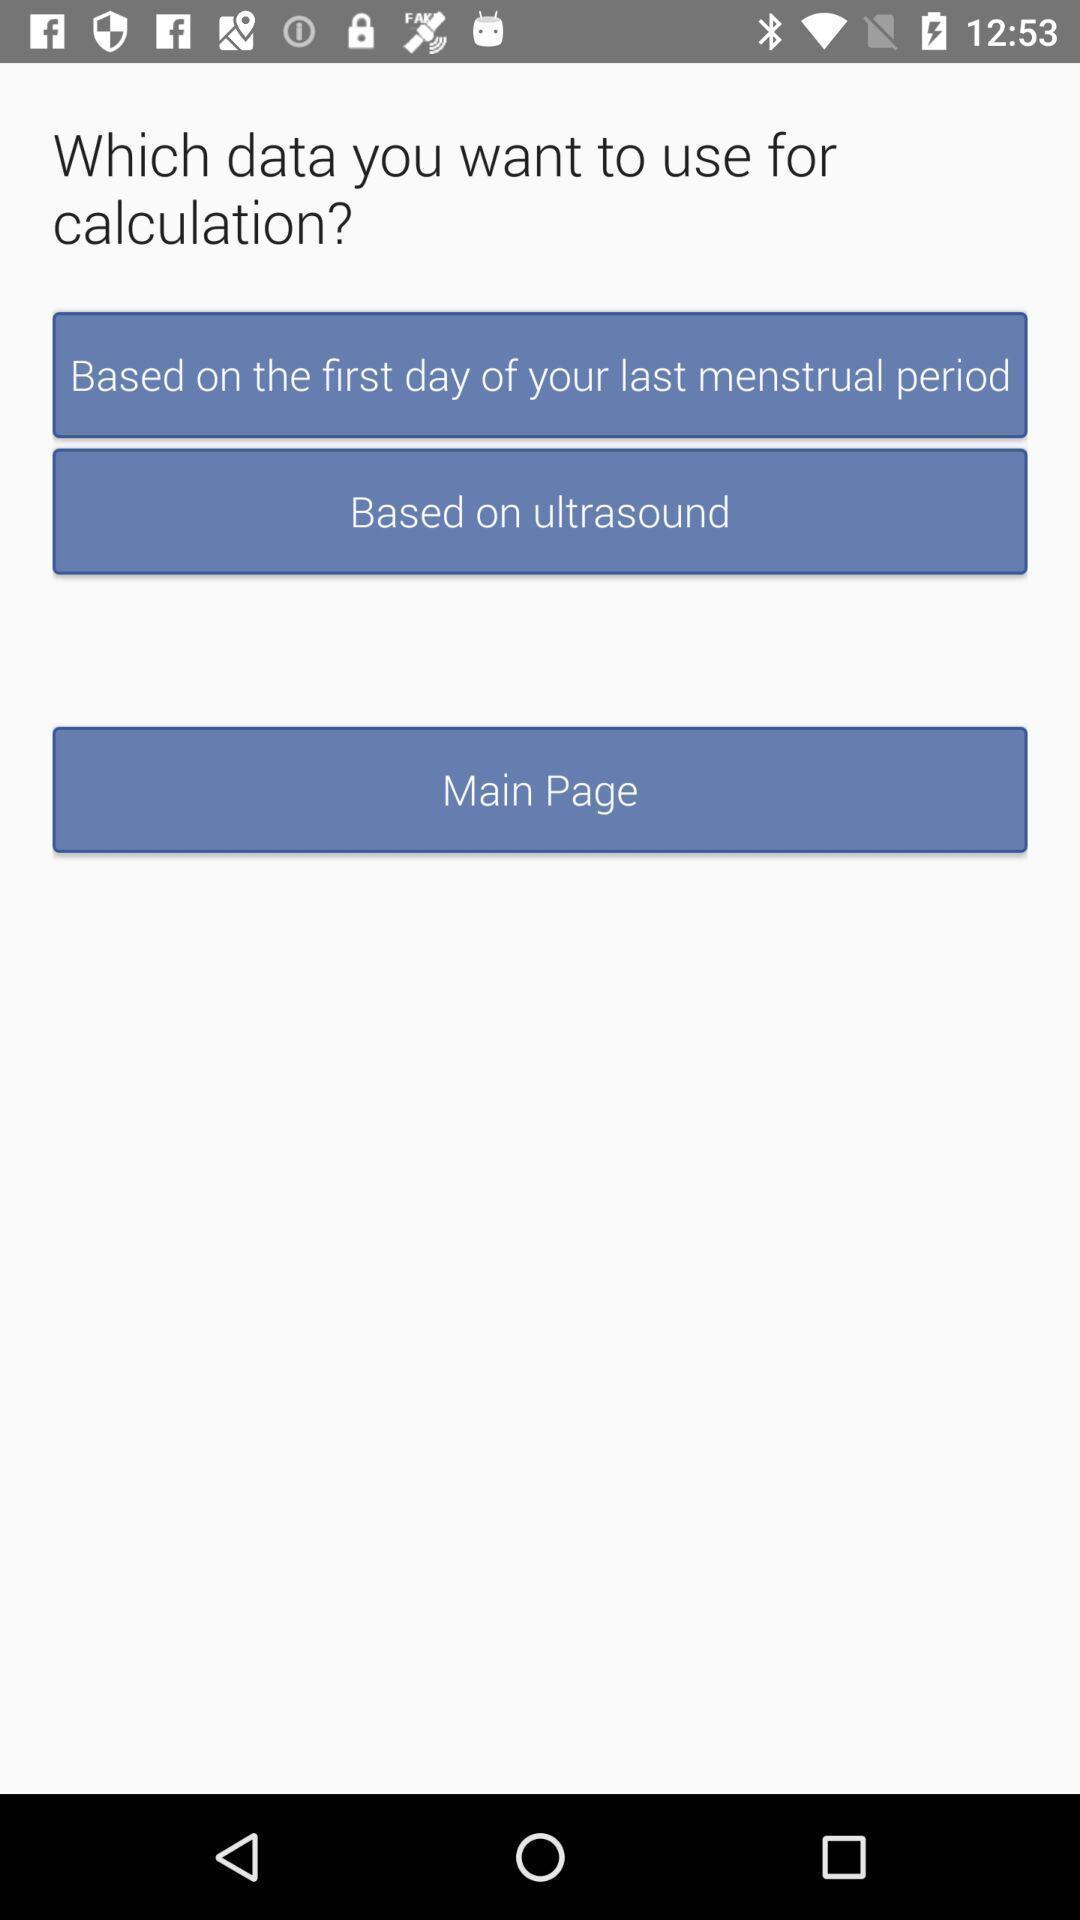Tell me about the visual elements in this screen capture. Screen showing various options to use for calculation. 